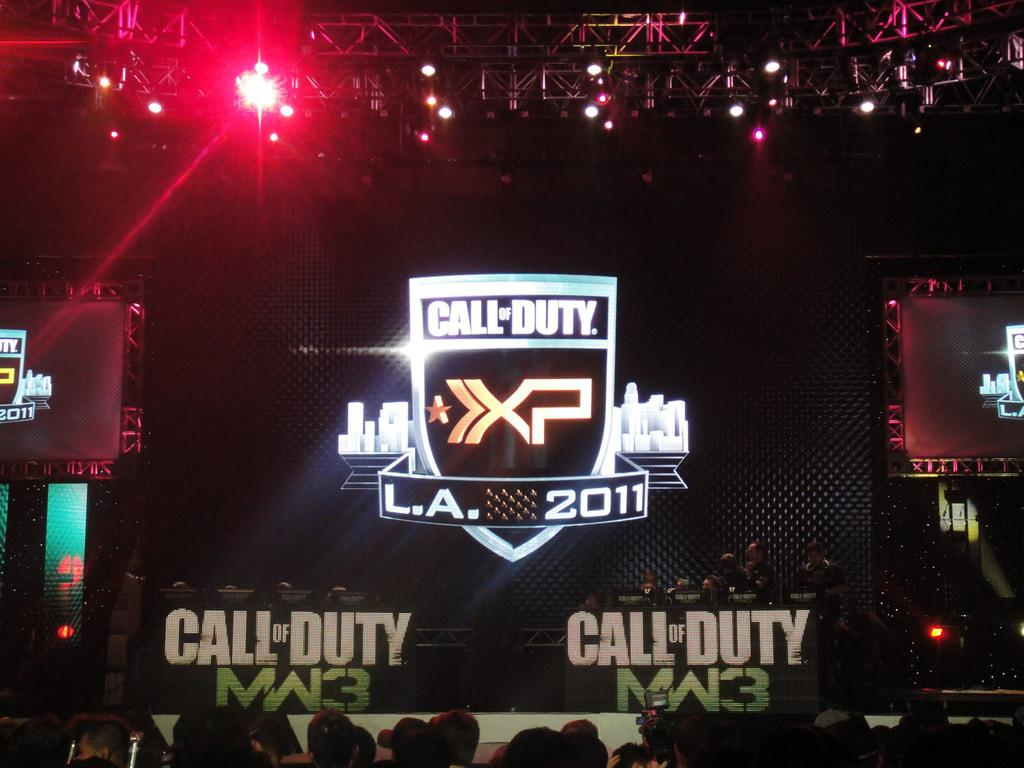<image>
Create a compact narrative representing the image presented. A sign at the back of the stage says Call of Duty LA 2011. 